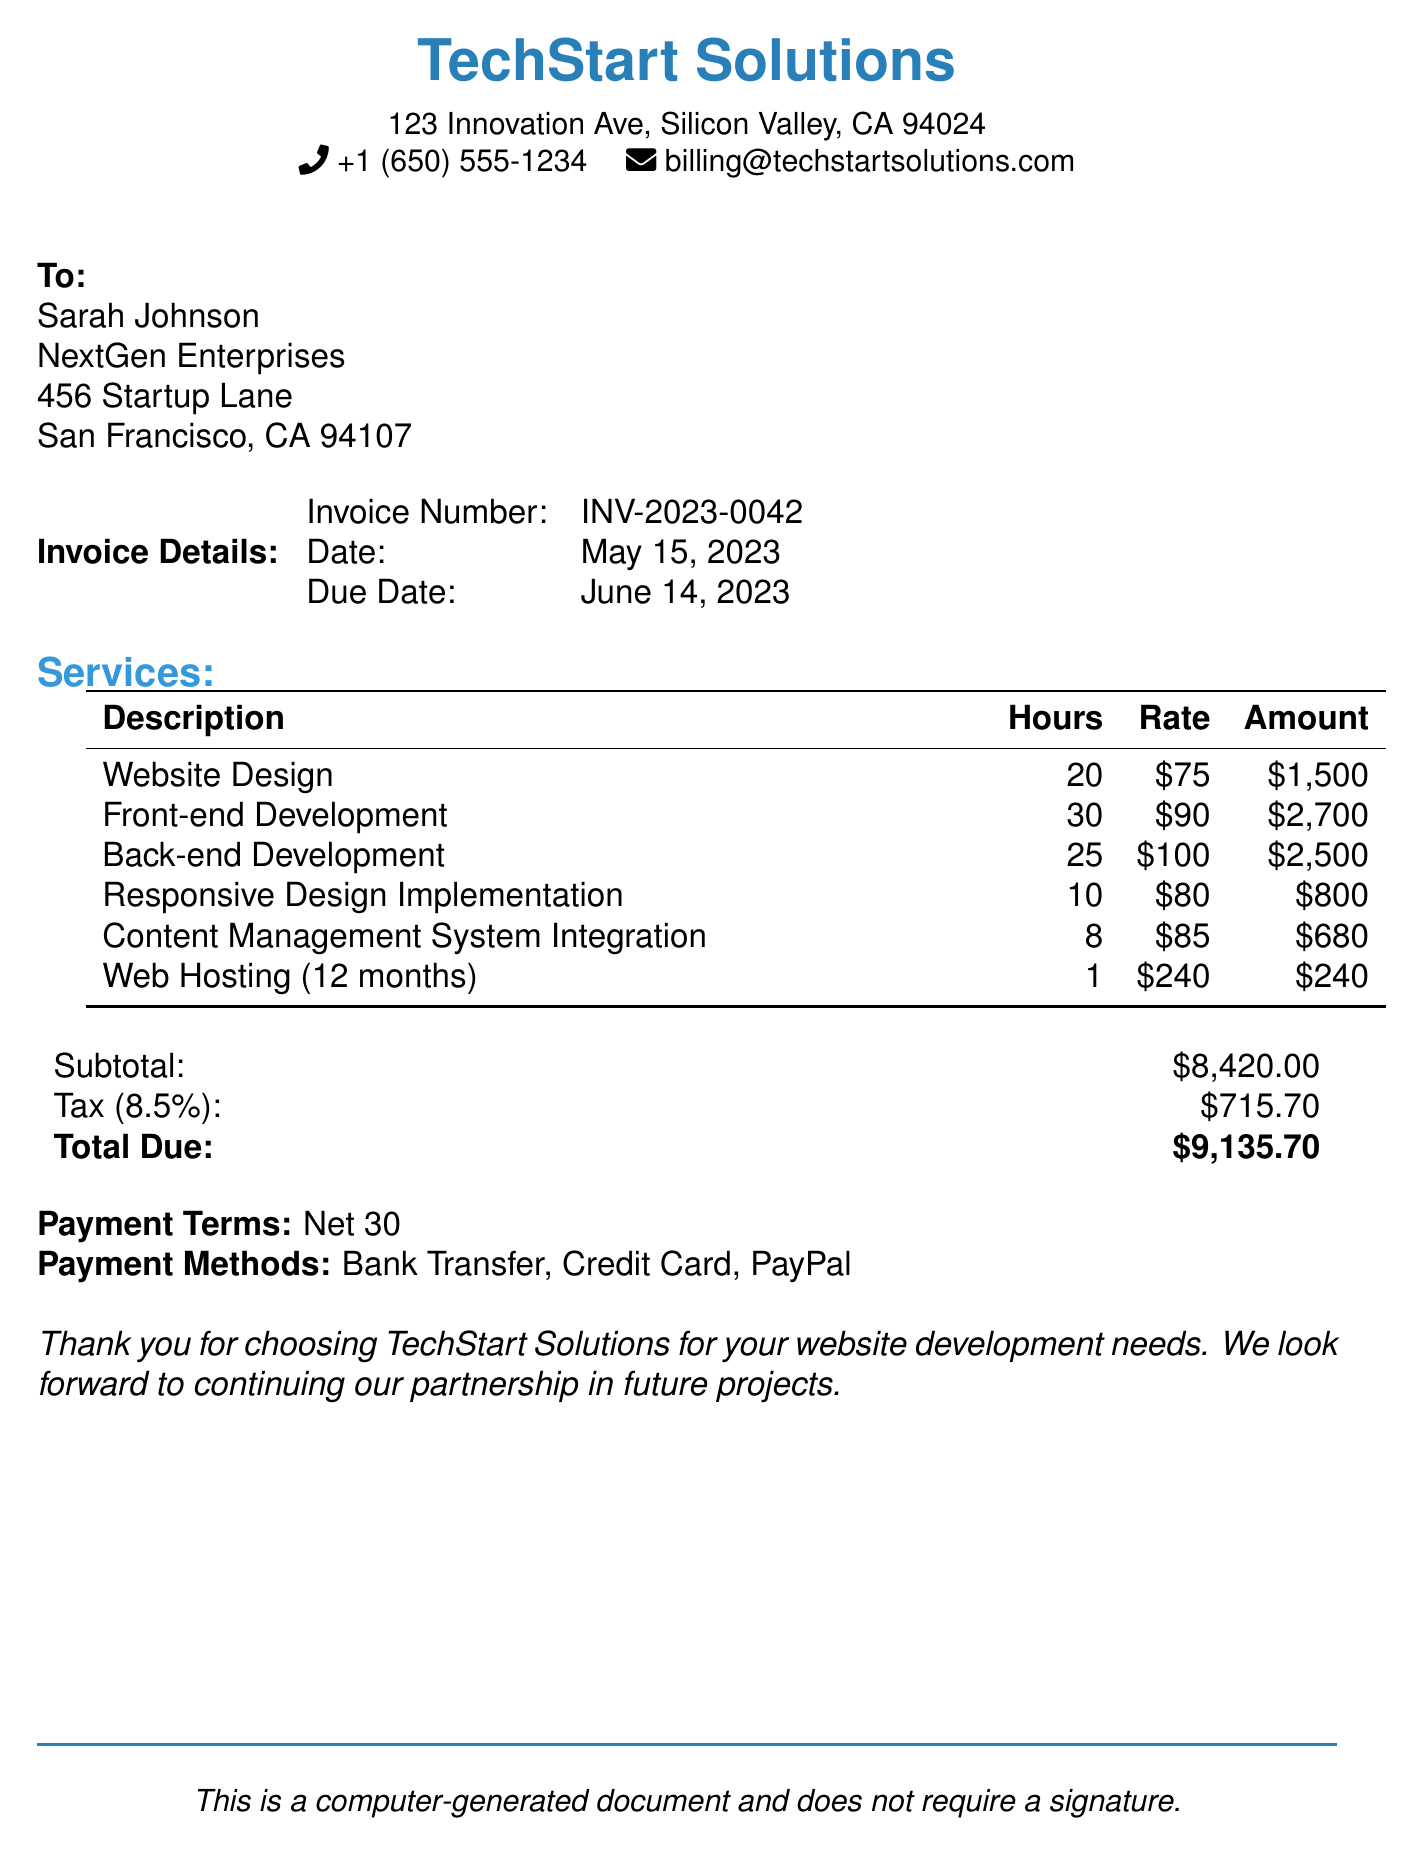What is the invoice number? The invoice number is located under the Invoice Details section.
Answer: INV-2023-0042 What is the total due amount? The total due amount is listed at the end of the invoice summary.
Answer: $9,135.70 How many hours were spent on Front-end Development? The hours for Front-end Development can be found in the Services table.
Answer: 30 What is the tax rate applied to the invoice? The tax rate is mentioned alongside the tax calculations in the summary.
Answer: 8.5% Who is the recipient of the invoice? The recipient's name is at the beginning of the document after "To:".
Answer: Sarah Johnson What service had the highest fee? To determine the service with the highest fee, compare the amounts in the Services table.
Answer: Front-end Development What payment terms are specified in the invoice? The payment terms are found in the Payment Terms section of the document.
Answer: Net 30 What is the fee for Web Hosting? The fee for Web Hosting can be found in the Services table under the corresponding description.
Answer: $240 How many months does the Web Hosting cover? The duration for Web Hosting is specified in the services breakdown.
Answer: 12 months 